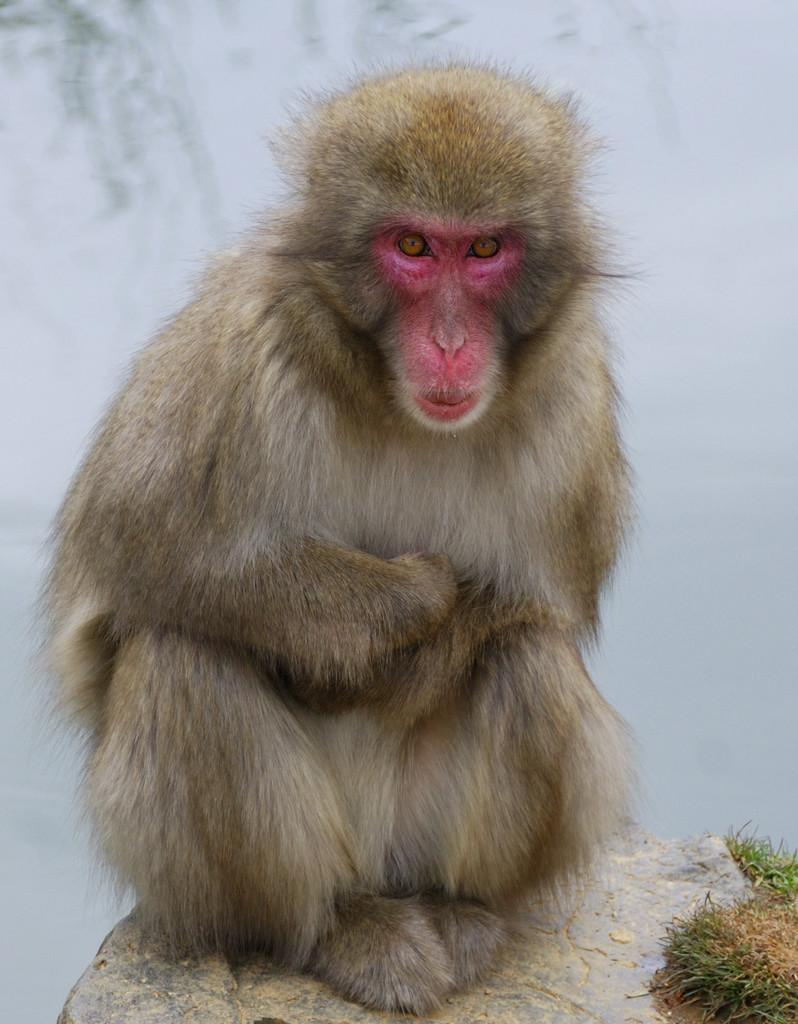What animal is present in the image? There is a monkey in the image. What is the monkey sitting on in the image? The monkey is sitting on a rock. Can you describe the background of the image? The background of the image is blurry. Are there any men working at the harbor in the image? There is no harbor or men present in the image; it features a monkey sitting on a rock with a blurry background. 